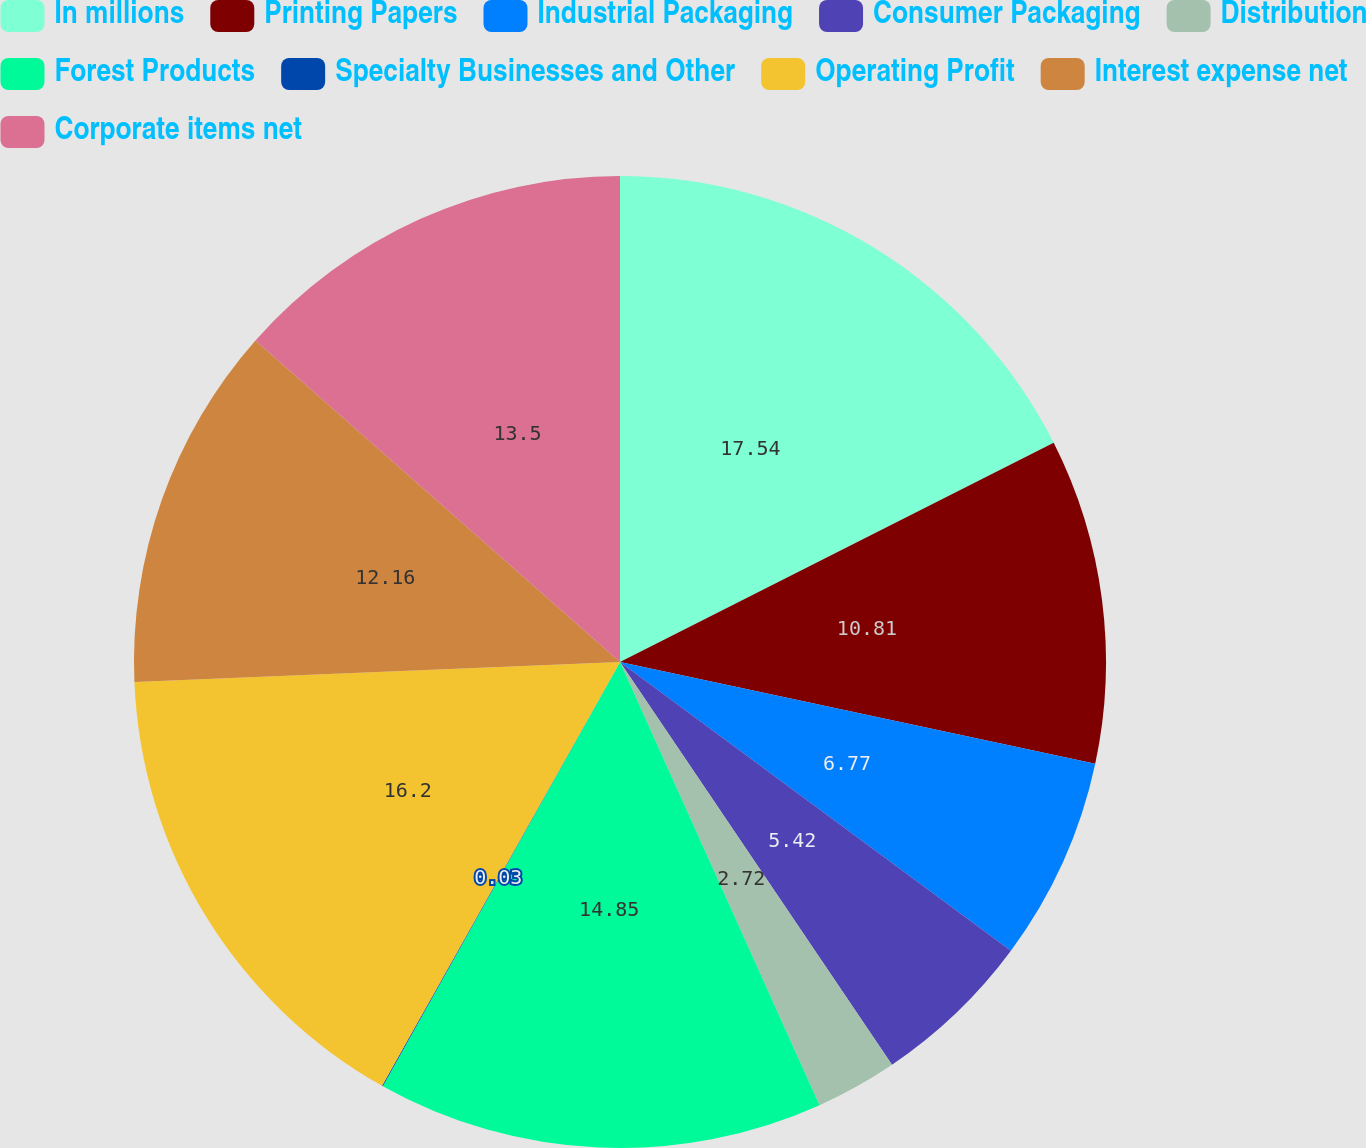Convert chart to OTSL. <chart><loc_0><loc_0><loc_500><loc_500><pie_chart><fcel>In millions<fcel>Printing Papers<fcel>Industrial Packaging<fcel>Consumer Packaging<fcel>Distribution<fcel>Forest Products<fcel>Specialty Businesses and Other<fcel>Operating Profit<fcel>Interest expense net<fcel>Corporate items net<nl><fcel>17.55%<fcel>10.81%<fcel>6.77%<fcel>5.42%<fcel>2.72%<fcel>14.85%<fcel>0.03%<fcel>16.2%<fcel>12.16%<fcel>13.5%<nl></chart> 